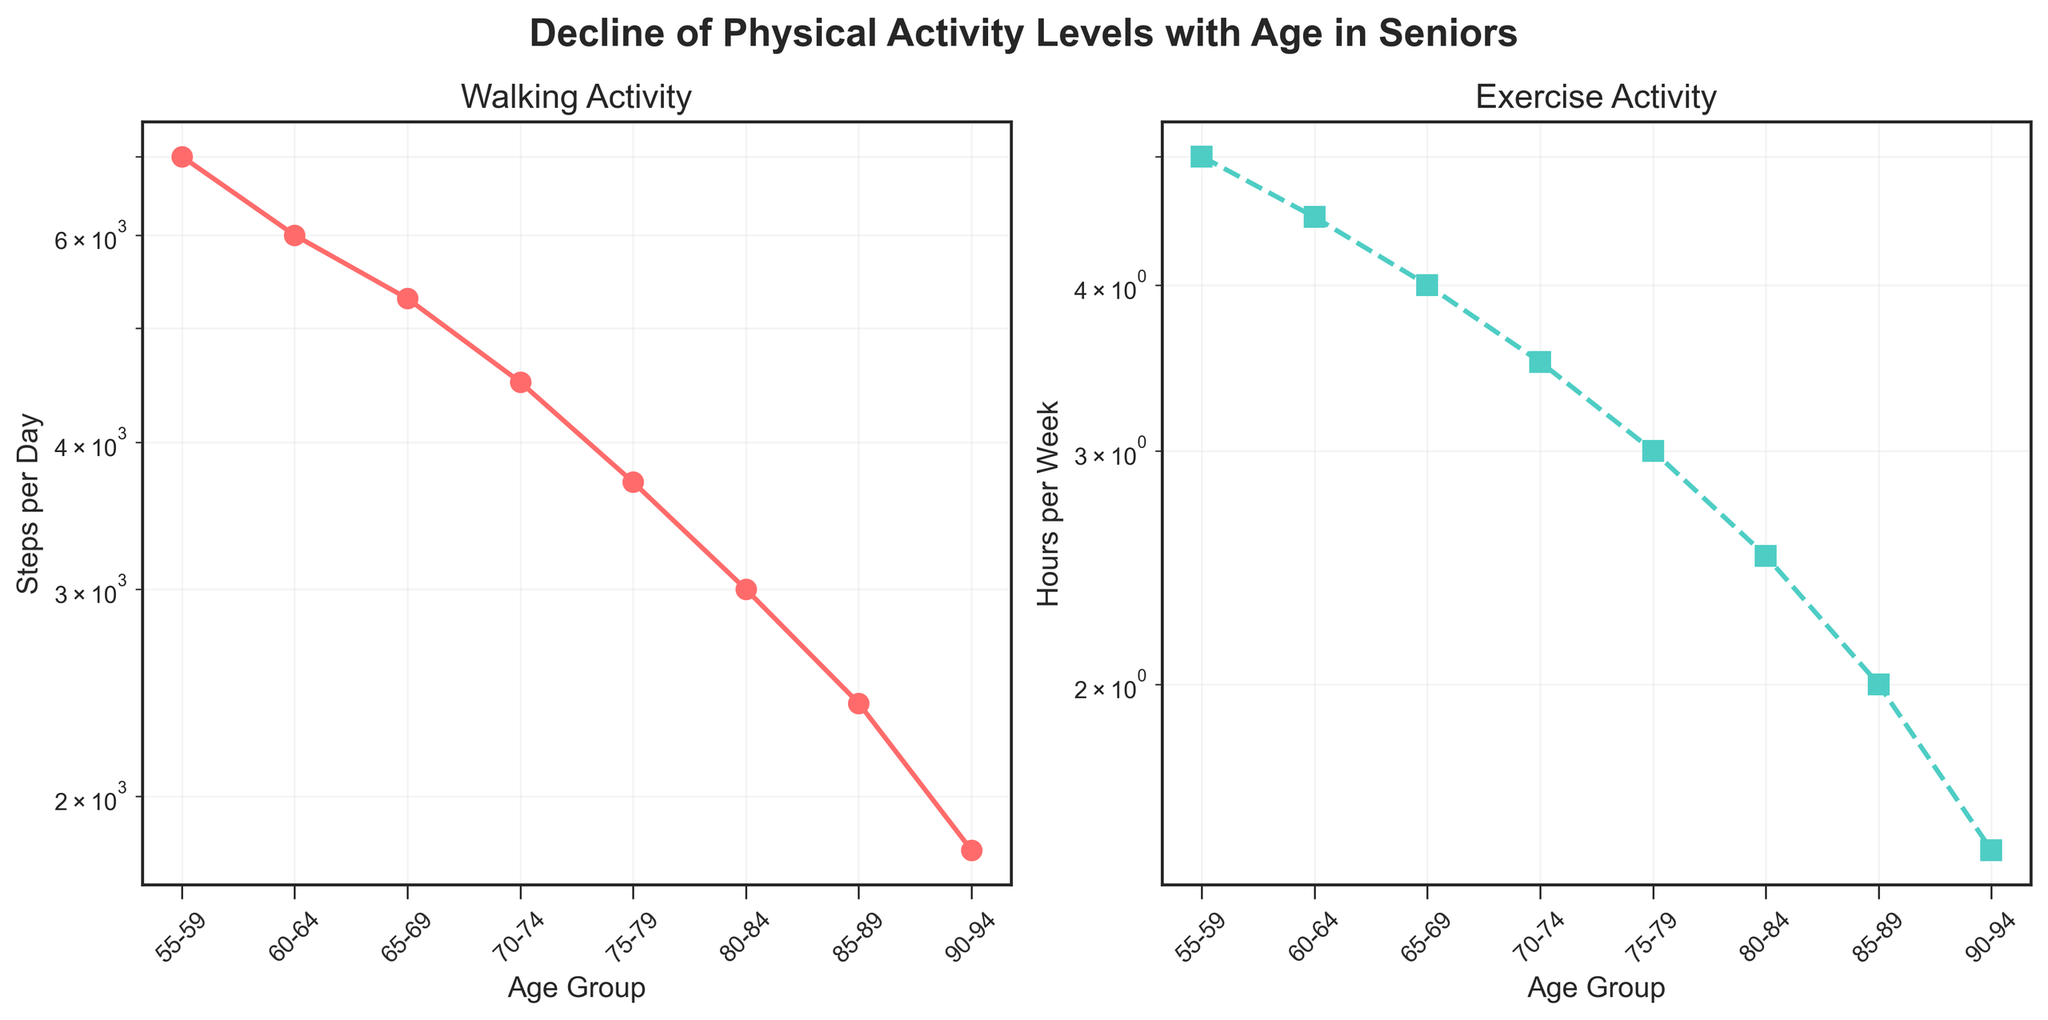How does the number of steps per day change from the 55-59 age group to the 90-94 age group? The figure shows a line plot where you can observe the steps per day decreasing as the age group increases. Specifically, the number of steps per day starts at 7000 in the 55-59 age group and drops to 1800 in the 90-94 age group.
Answer: The steps per day drop from 7000 to 1800 How many age groups are represented in each plot? There are eight different age groups represented in each of the two subplots. These age groups are 55-59, 60-64, 65-69, 70-74, 75-79, 80-84, 85-89, and 90-94.
Answer: 8 Which age group has the highest exercise activity level? From the subplot on the right, titled 'Exercise Activity,' the highest activity level is in the 55-59 age group with 5 hours per week.
Answer: 55-59 Between which two consecutive age groups is the largest decrease in walking activity seen? By looking at the 'Walking Activity' subplot (with a log scale), the largest decrease occurs from the 75-79 age group (3700 steps per day) to the 80-84 age group (3000 steps per day). Specifically, the decrease is 700 steps per day.
Answer: From 75-79 to 80-84 What is the average number of steps per day in the age groups 60-64 and 70-74? Sum the physical activity level (steps per day) for the age groups 60-64 and 70-74, and then divide by 2. For age groups 60-64 and 70-74, the values are 6000 and 4500 respectively. (6000 + 4500) / 2 = 5250.
Answer: 5250 steps per day Compare the exercise activity levels between the 65-69 and 85-89 age groups. In the 'Exercise Activity' subplot, the 65-69 age group has an activity level of 4 hours per week, whereas the 85-89 age group has 2 hours per week. This shows that the exercise activity level for the 65-69 age group is double that of the 85-89 age group.
Answer: The 65-69 age group has double the exercise activity Does the walking activity level ever fall below 2000 steps per day? If so, which age group(s)? According to the 'Walking Activity' subplot, the 85-89 and 90-94 age groups show walking activity levels below 2000 steps per day, with values of 2400 and 1800 steps per day, respectively. Hence, only the 90-94 age group falls below 2000 steps per day.
Answer: Only 90-94 Do the steps per day decrease more steeply compared to hours of exercise per week as age increases? Both subplots indicate a log scale for easier comparison. By visual inspection, the slope of the line representing steps per day (walking activity) appears steeper than that of hours of exercise per week, indicating a more rapid decrease in walking activity with age.
Answer: Yes How much does exercise activity decrease on average per decade starting from 55-59 to 85-89? Calculate the difference in exercise activity level for each decade and then find the average. (55-59) = 5, (65-69) = 4, (75-79) = 3, (85-89) = 2. Differences: (5-4)/(10), (4-3)/(10), (3-2)/(10). Average = ((1/10) + (1/10) + (1/10))/3 = 0.1 hours per week per decade.
Answer: 1 hour per decade 